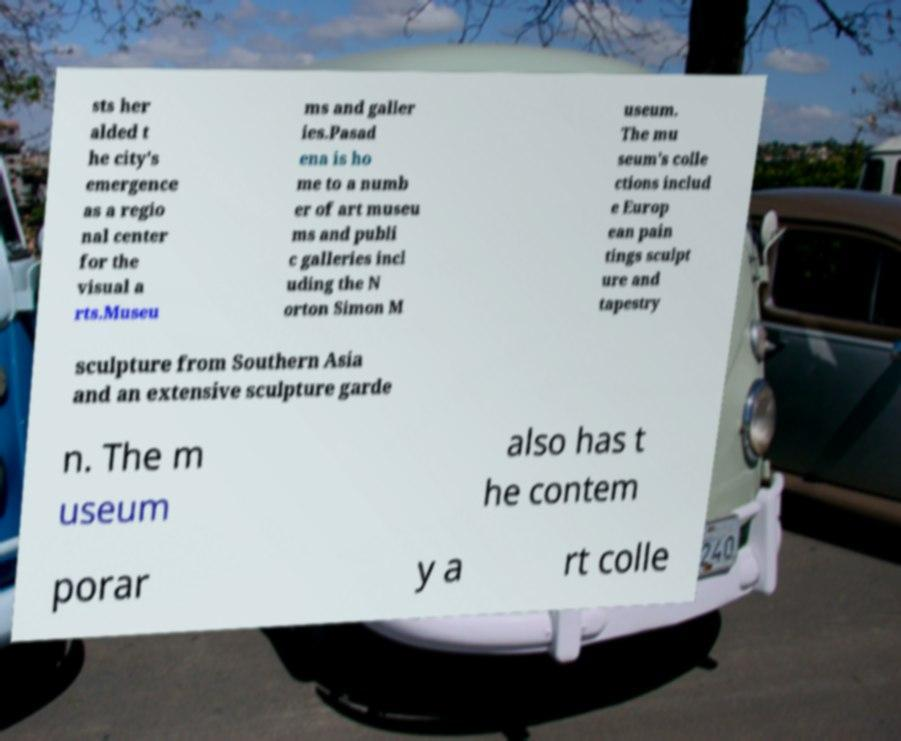There's text embedded in this image that I need extracted. Can you transcribe it verbatim? sts her alded t he city's emergence as a regio nal center for the visual a rts.Museu ms and galler ies.Pasad ena is ho me to a numb er of art museu ms and publi c galleries incl uding the N orton Simon M useum. The mu seum's colle ctions includ e Europ ean pain tings sculpt ure and tapestry sculpture from Southern Asia and an extensive sculpture garde n. The m useum also has t he contem porar y a rt colle 